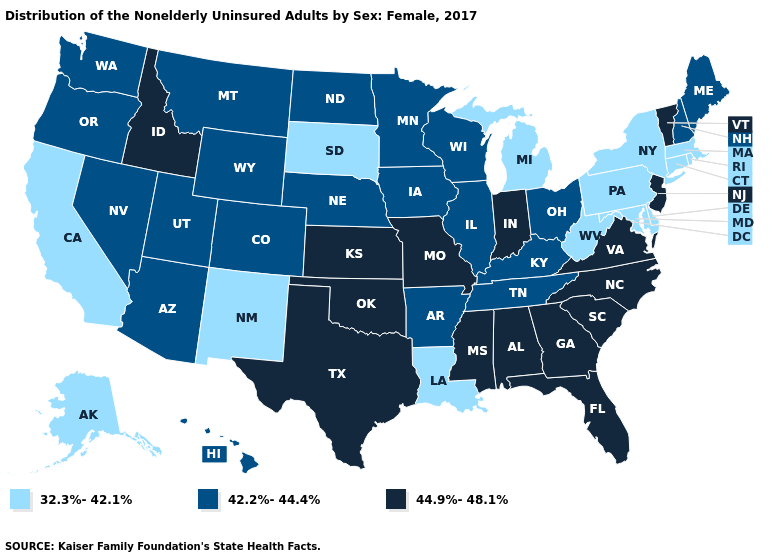What is the value of Alaska?
Answer briefly. 32.3%-42.1%. What is the value of Rhode Island?
Concise answer only. 32.3%-42.1%. What is the value of Montana?
Concise answer only. 42.2%-44.4%. Which states hav the highest value in the Northeast?
Answer briefly. New Jersey, Vermont. What is the value of Ohio?
Answer briefly. 42.2%-44.4%. Which states have the lowest value in the USA?
Short answer required. Alaska, California, Connecticut, Delaware, Louisiana, Maryland, Massachusetts, Michigan, New Mexico, New York, Pennsylvania, Rhode Island, South Dakota, West Virginia. What is the value of Georgia?
Give a very brief answer. 44.9%-48.1%. Does Minnesota have the highest value in the MidWest?
Write a very short answer. No. What is the highest value in the West ?
Answer briefly. 44.9%-48.1%. Among the states that border New Mexico , does Texas have the highest value?
Answer briefly. Yes. Which states have the lowest value in the USA?
Quick response, please. Alaska, California, Connecticut, Delaware, Louisiana, Maryland, Massachusetts, Michigan, New Mexico, New York, Pennsylvania, Rhode Island, South Dakota, West Virginia. What is the value of South Dakota?
Answer briefly. 32.3%-42.1%. Does Wisconsin have a higher value than Louisiana?
Write a very short answer. Yes. What is the highest value in the USA?
Concise answer only. 44.9%-48.1%. Does South Dakota have the highest value in the MidWest?
Concise answer only. No. 